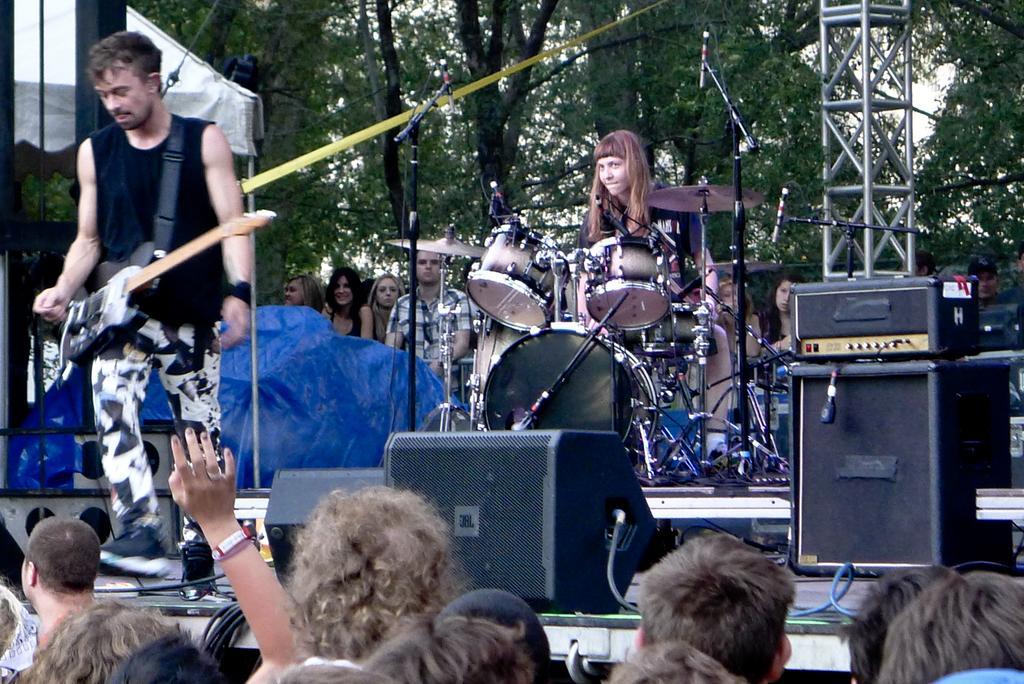Describe this image in one or two sentences. This picture is clicked outside the city. Here, we see man in black t-shirt is holding guitar and in the middle of the picture, we see woman in black t-shirt is playing drums. In front of them, we see speakers. On the bottom of the picture, we see many people standing and enjoying the music. Behind the man in black t-shirt, we see a cover which is blue in color and behind that, we see many people standing and on background, we see trees and on the right corner of the picture, we see pillar. 